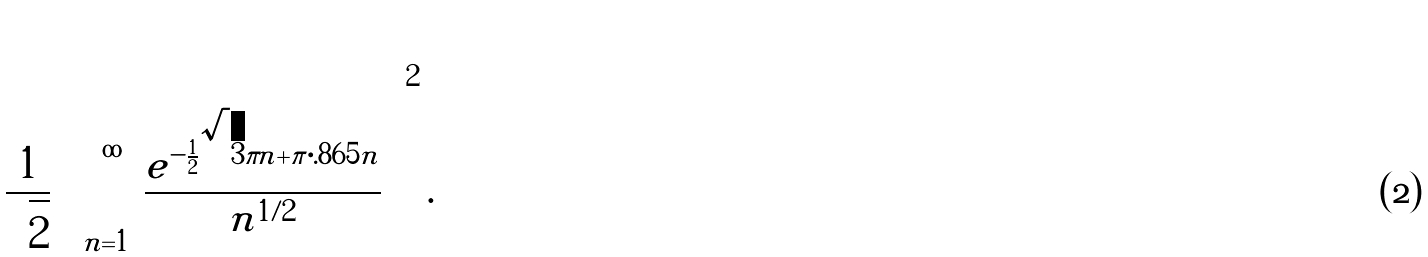Convert formula to latex. <formula><loc_0><loc_0><loc_500><loc_500>\frac { 1 } { \sqrt { 2 } } \left ( \sum _ { n = 1 } ^ { \infty } \frac { e ^ { - \frac { 1 } { 2 } \sqrt { 3 } \pi n + \pi \cdot . 8 6 5 n } } { n ^ { 1 / 2 } } \right ) ^ { 2 } .</formula> 